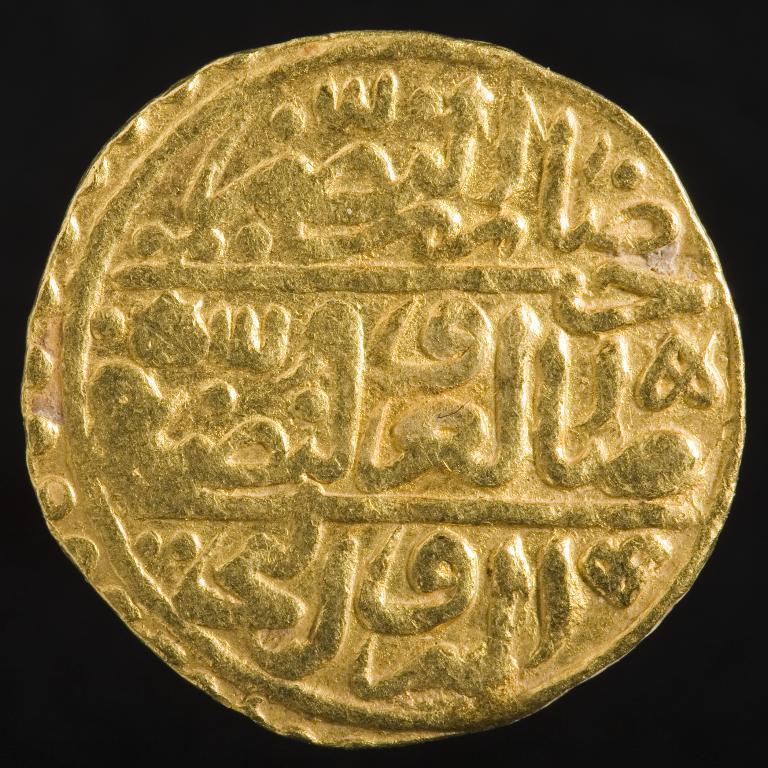Describe this image in one or two sentences. In this image we can see a gold color object with some carved text on it. And we can see the black background. 